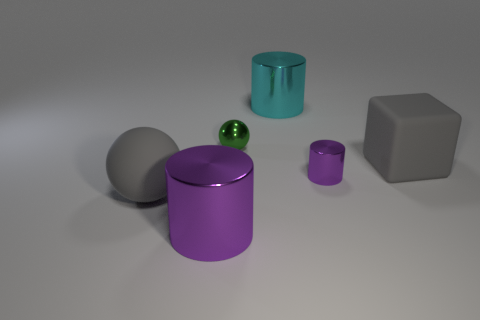Subtract all red spheres. How many purple cylinders are left? 2 Add 3 metal things. How many objects exist? 9 Subtract all big cyan cylinders. How many cylinders are left? 2 Subtract all balls. How many objects are left? 4 Subtract all yellow cylinders. Subtract all red spheres. How many cylinders are left? 3 Subtract all brown metal spheres. Subtract all tiny green spheres. How many objects are left? 5 Add 3 cyan cylinders. How many cyan cylinders are left? 4 Add 6 tiny red matte things. How many tiny red matte things exist? 6 Subtract 0 blue cylinders. How many objects are left? 6 